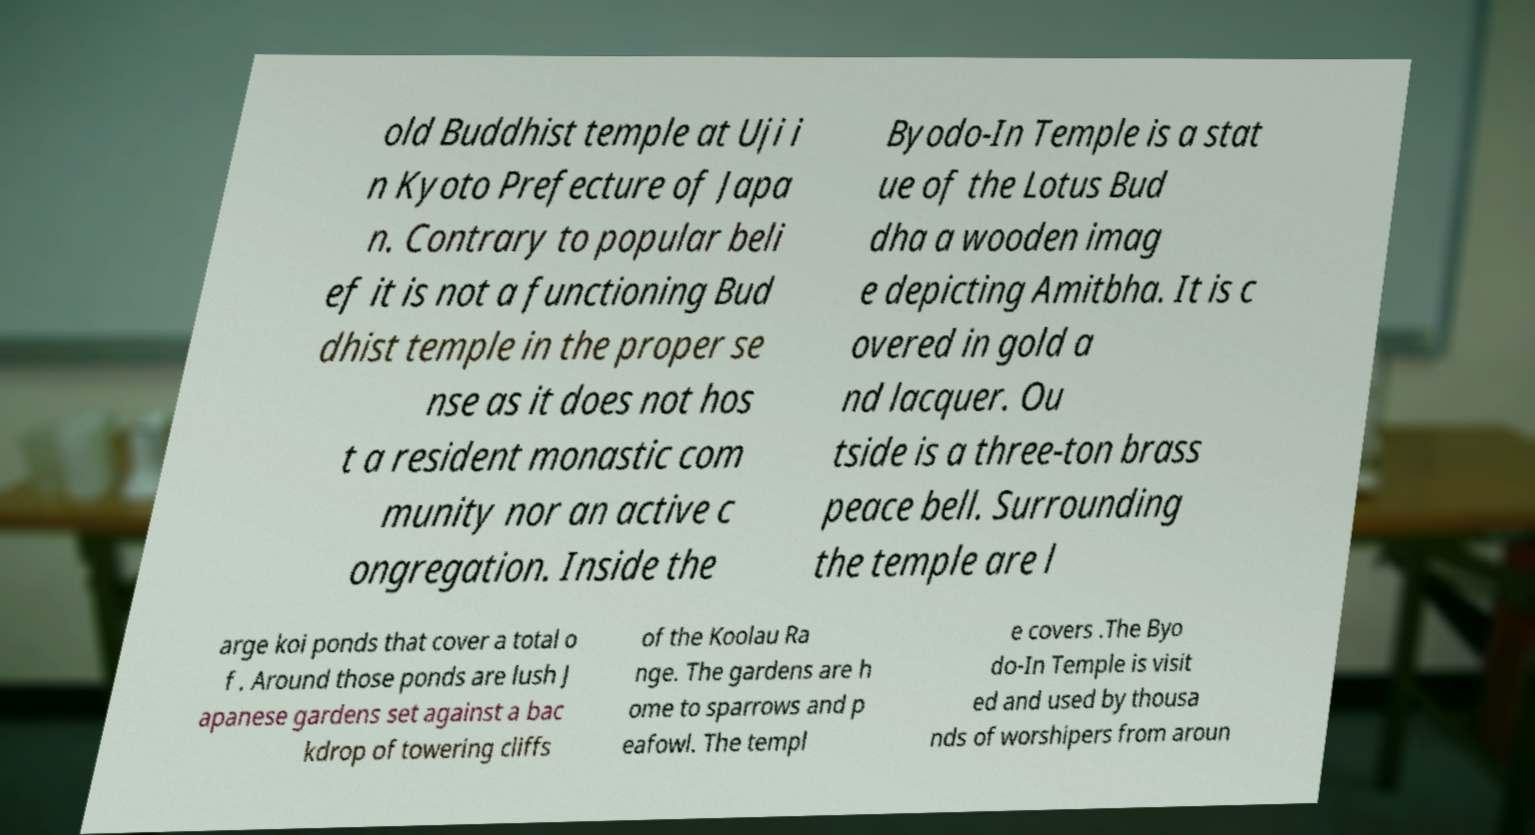Could you assist in decoding the text presented in this image and type it out clearly? old Buddhist temple at Uji i n Kyoto Prefecture of Japa n. Contrary to popular beli ef it is not a functioning Bud dhist temple in the proper se nse as it does not hos t a resident monastic com munity nor an active c ongregation. Inside the Byodo-In Temple is a stat ue of the Lotus Bud dha a wooden imag e depicting Amitbha. It is c overed in gold a nd lacquer. Ou tside is a three-ton brass peace bell. Surrounding the temple are l arge koi ponds that cover a total o f . Around those ponds are lush J apanese gardens set against a bac kdrop of towering cliffs of the Koolau Ra nge. The gardens are h ome to sparrows and p eafowl. The templ e covers .The Byo do-In Temple is visit ed and used by thousa nds of worshipers from aroun 